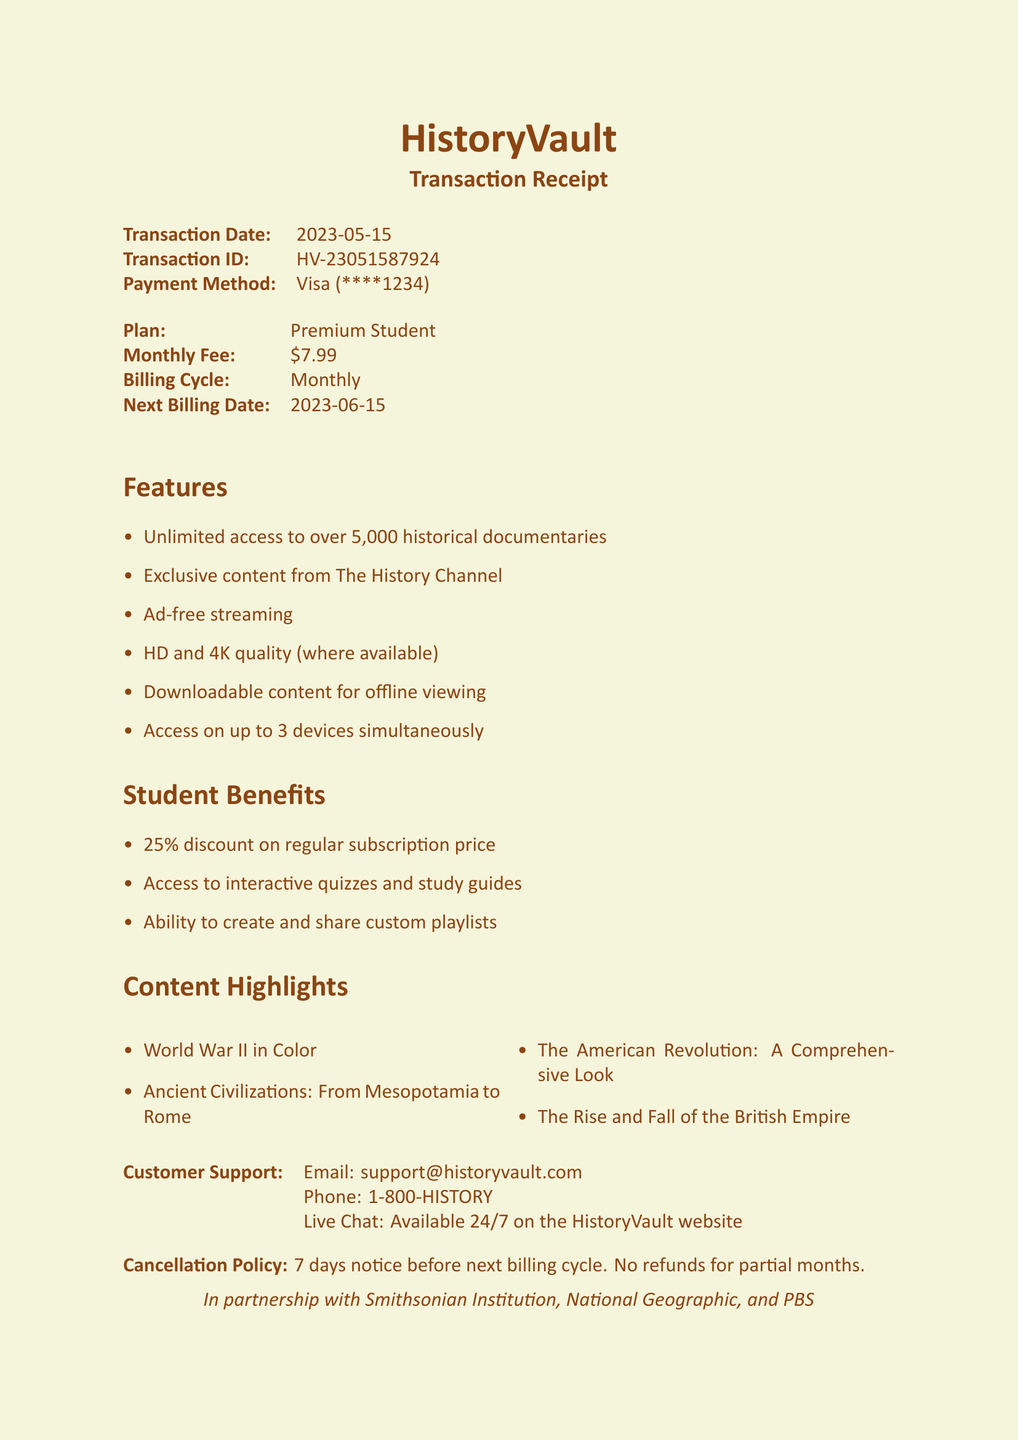What is the name of the service? The document states the service name as "HistoryVault".
Answer: HistoryVault What is the monthly fee for the subscription? The document lists the monthly fee under subscription info as "$7.99".
Answer: $7.99 What is the next billing date? According to the document, the next billing date is provided in the subscription info.
Answer: 2023-06-15 What features allow offline viewing? The feature list includes "Downloadable content for offline viewing".
Answer: Downloadable content for offline viewing How many devices can access the content simultaneously? The document specifies in the features that access is available on "up to 3 devices simultaneously".
Answer: 3 devices What percentage discount do students receive? The document indicates that students get a "25% discount on regular subscription price".
Answer: 25% What is the notice period for cancellation? The cancellation policy mentions a notice period of "7 days before next billing cycle".
Answer: 7 days Which institution is a partner with HistoryVault? The document lists several partners, with "Smithsonian Institution" as one example.
Answer: Smithsonian Institution What types of content highlights are included? The content highlights section lists titles such as "World War II in Color".
Answer: World War II in Color 